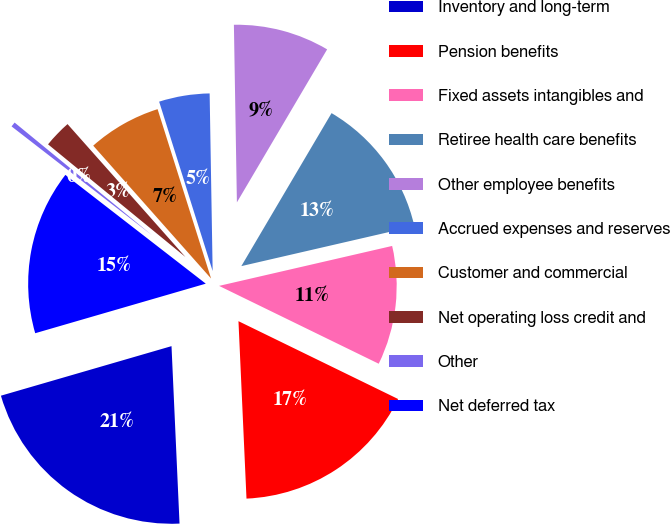Convert chart. <chart><loc_0><loc_0><loc_500><loc_500><pie_chart><fcel>Inventory and long-term<fcel>Pension benefits<fcel>Fixed assets intangibles and<fcel>Retiree health care benefits<fcel>Other employee benefits<fcel>Accrued expenses and reserves<fcel>Customer and commercial<fcel>Net operating loss credit and<fcel>Other<fcel>Net deferred tax<nl><fcel>21.22%<fcel>17.06%<fcel>10.83%<fcel>12.91%<fcel>8.75%<fcel>4.6%<fcel>6.68%<fcel>2.52%<fcel>0.44%<fcel>14.99%<nl></chart> 